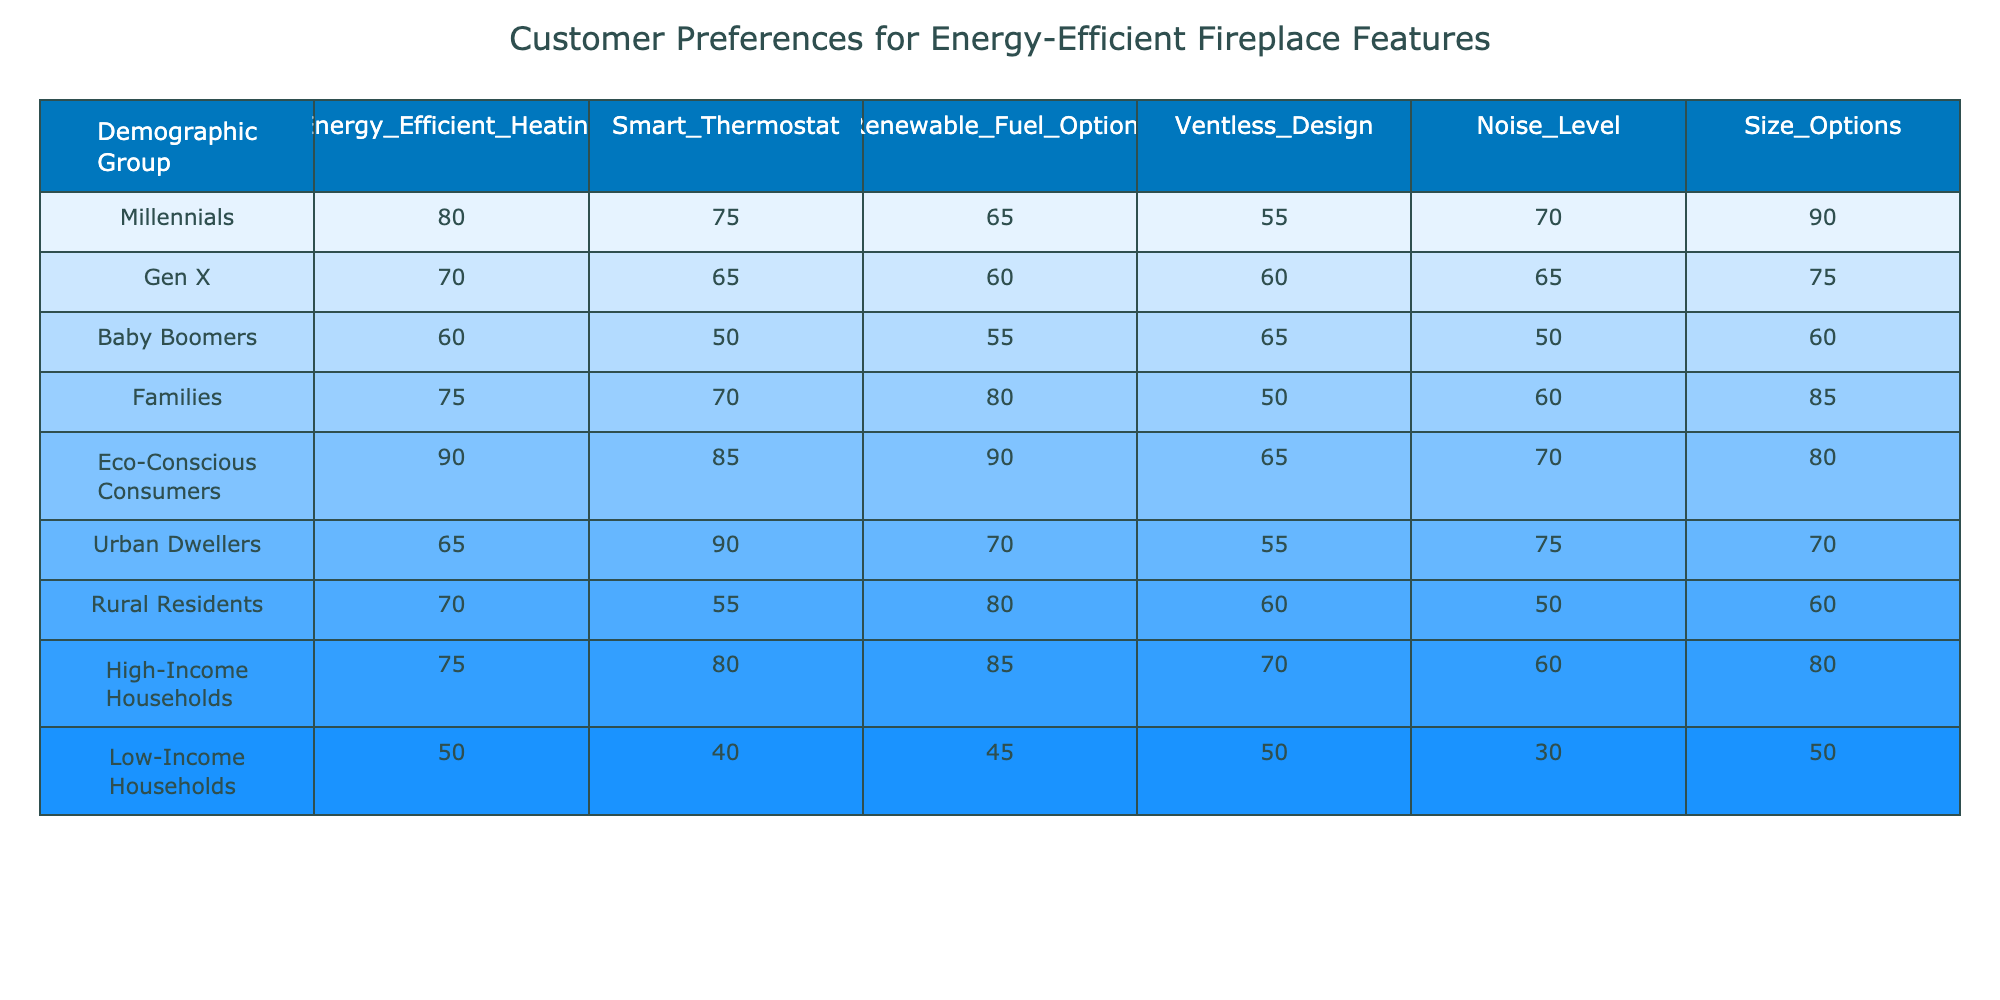What demographic group shows the highest preference for Renewable Fuel Options? The table indicates that Eco-Conscious Consumers have the highest preference for Renewable Fuel Options, with a score of 90.
Answer: Eco-Conscious Consumers What is the average score for Smart Thermostat preferences among all demographic groups? To calculate the average for Smart Thermostat, we add scores: (75 + 65 + 50 + 70 + 85 + 90 + 55 + 80 + 40) = 660. There are 9 groups, so the average is 660 divided by 9, which equals approximately 73.33.
Answer: 73.33 Do Urban Dwellers prefer Ventless Design more than Baby Boomers? Urban Dwellers have a preference score of 55 for Ventless Design, while Baby Boomers have a score of 65. Since 55 is less than 65, the statement is false.
Answer: No Which demographic group has the lowest score for Noise Level? A look at the Noise Level column shows that Low-Income Households have the lowest score of 30.
Answer: Low-Income Households Is the preference for Size Options higher among Families compared to Low-Income Households? Families have a preference score of 85 for Size Options, while Low-Income Households have a score of 50. Since 85 is greater than 50, the answer is yes.
Answer: Yes What is the difference in preference for Energy Efficient Heating between Eco-Conscious Consumers and Baby Boomers? Eco-Conscious Consumers score 90 for Energy Efficient Heating and Baby Boomers score 60. The difference is 90 - 60 = 30.
Answer: 30 Which group has a higher preference score for Smart Thermostat: Millennials or Families? The table shows Millennials with a score of 75 for Smart Thermostat and Families with a score of 70. Therefore, Millennials have a higher preference.
Answer: Millennials What is the total score for features among High-Income Households? High-Income Households' scores are: Energy Efficient Heating (75) + Smart Thermostat (80) + Renewable Fuel Options (85) + Ventless Design (70) + Noise Level (60) + Size Options (80). Summing these gives 450.
Answer: 450 Which demographic group shows the highest preference for Energy Efficient Heating, and by how much does it exceed that of Millennials? Eco-Conscious Consumers show the highest with a score of 90, while Millennials have a score of 80. The difference is 90 - 80 = 10.
Answer: 10 